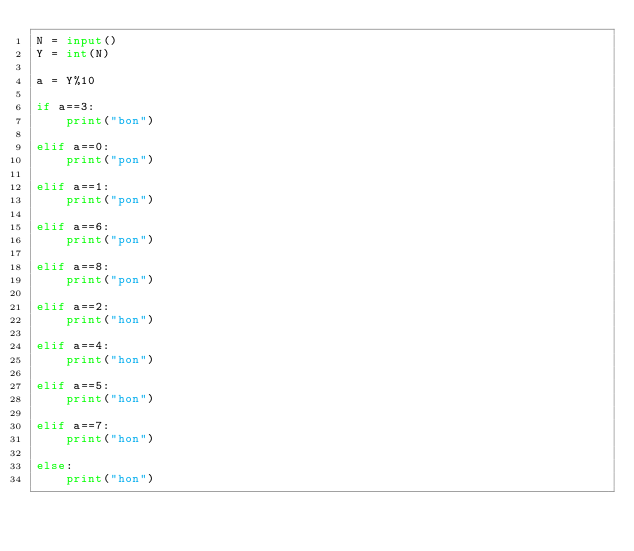<code> <loc_0><loc_0><loc_500><loc_500><_Python_>N = input()
Y = int(N)

a = Y%10

if a==3:
    print("bon")

elif a==0:
    print("pon")

elif a==1:
    print("pon")

elif a==6:
    print("pon")

elif a==8:
    print("pon")

elif a==2:
    print("hon")

elif a==4:
    print("hon")

elif a==5:
    print("hon")

elif a==7:
    print("hon")

else:
    print("hon")
</code> 